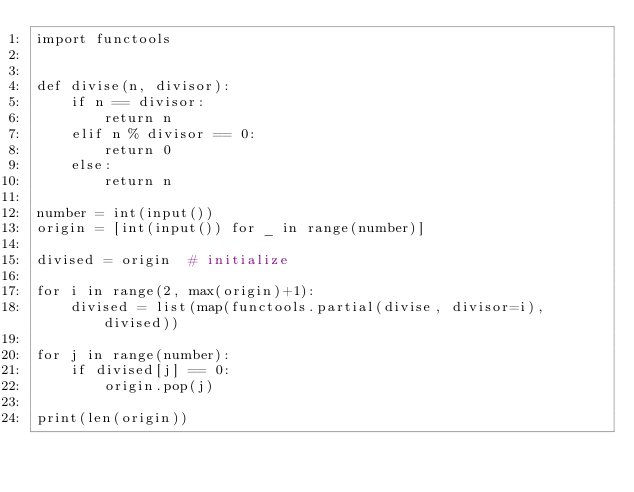Convert code to text. <code><loc_0><loc_0><loc_500><loc_500><_Python_>import functools


def divise(n, divisor):
    if n == divisor:
        return n
    elif n % divisor == 0:
        return 0
    else:
        return n

number = int(input())
origin = [int(input()) for _ in range(number)]

divised = origin  # initialize

for i in range(2, max(origin)+1):
    divised = list(map(functools.partial(divise, divisor=i), divised))

for j in range(number):
    if divised[j] == 0:
        origin.pop(j)

print(len(origin))</code> 